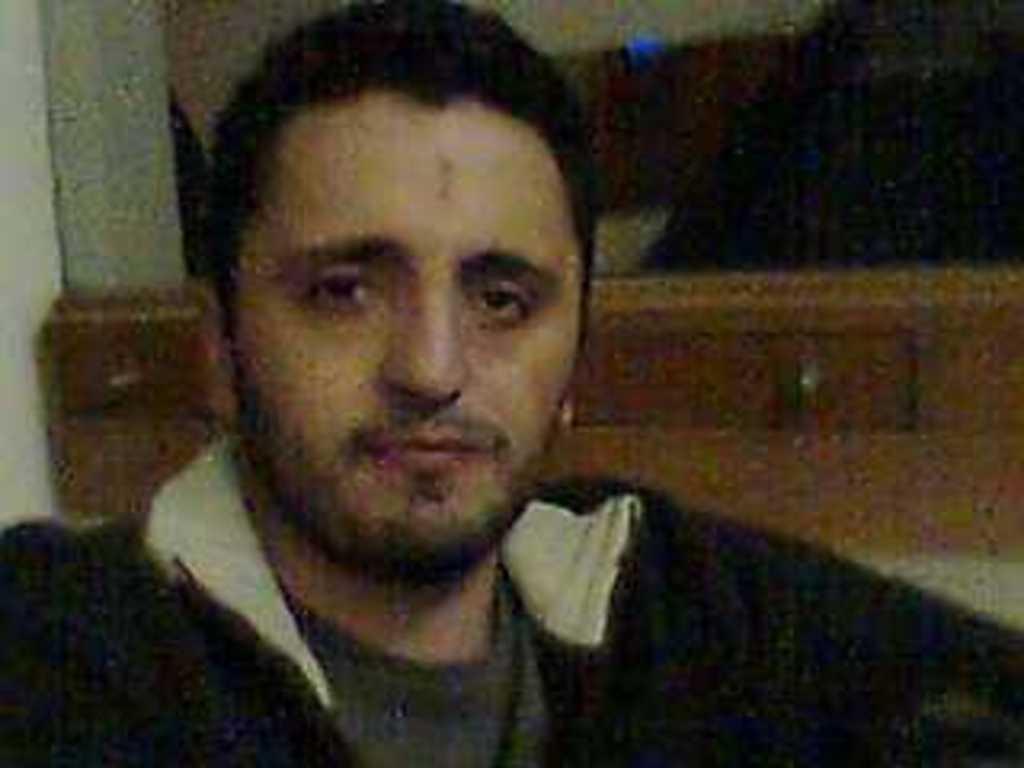Please provide a concise description of this image. In the foreground of this image, there is a man and the background image is not clear. 